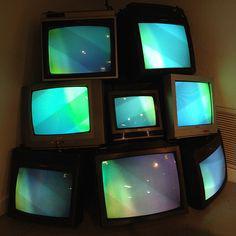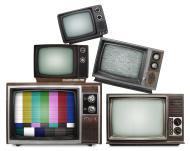The first image is the image on the left, the second image is the image on the right. For the images displayed, is the sentence "The televisions in the left image appear to be powered on." factually correct? Answer yes or no. Yes. 